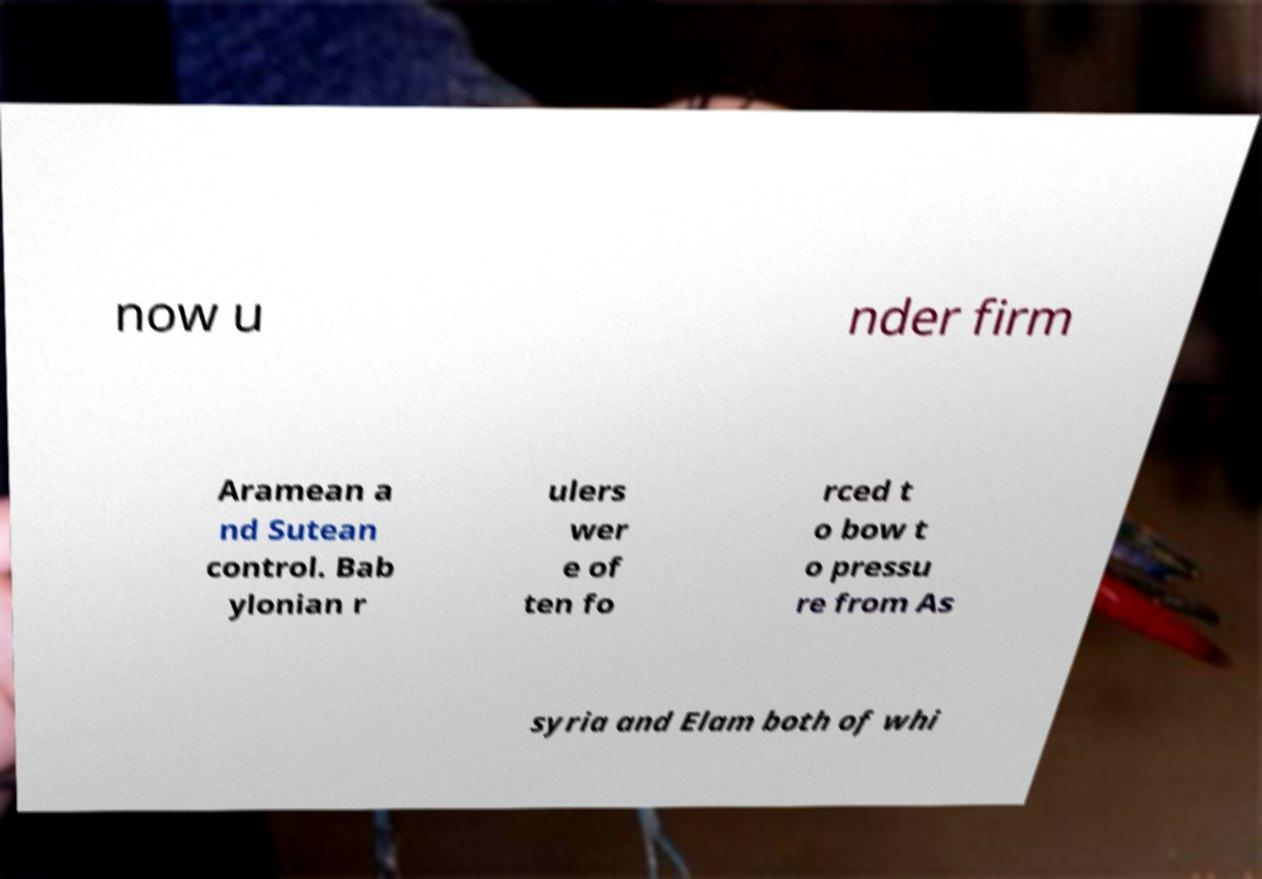Please read and relay the text visible in this image. What does it say? now u nder firm Aramean a nd Sutean control. Bab ylonian r ulers wer e of ten fo rced t o bow t o pressu re from As syria and Elam both of whi 